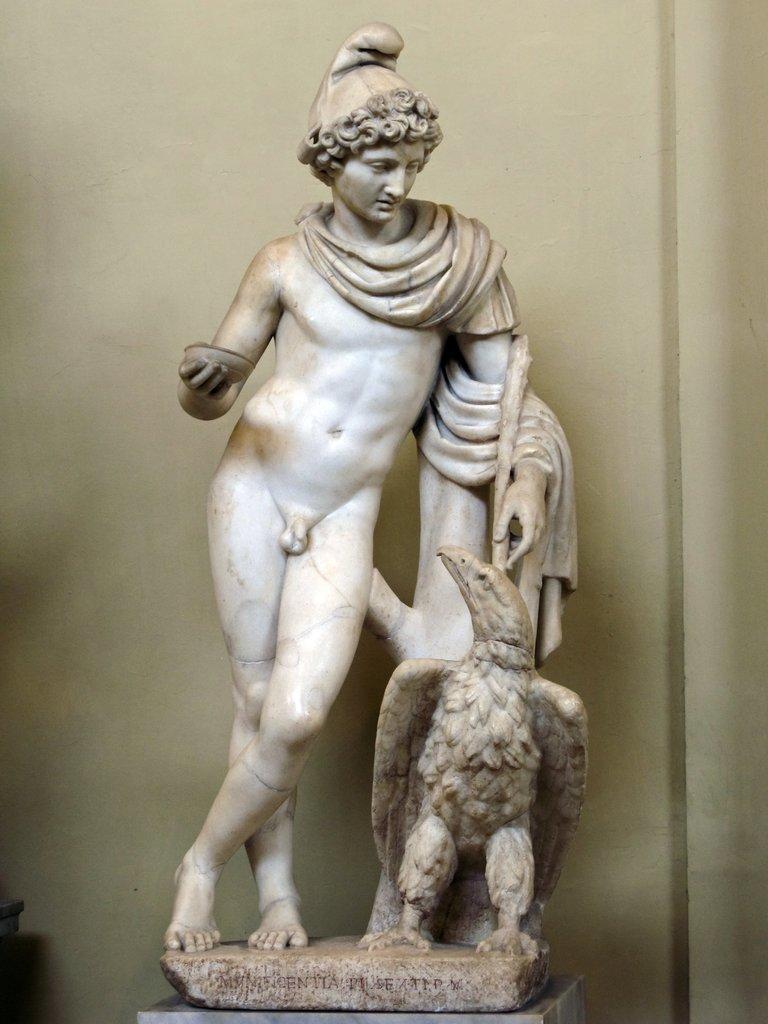Please provide a concise description of this image. In the center of the image we can see a statue. In the background of the image we can see the wall. 